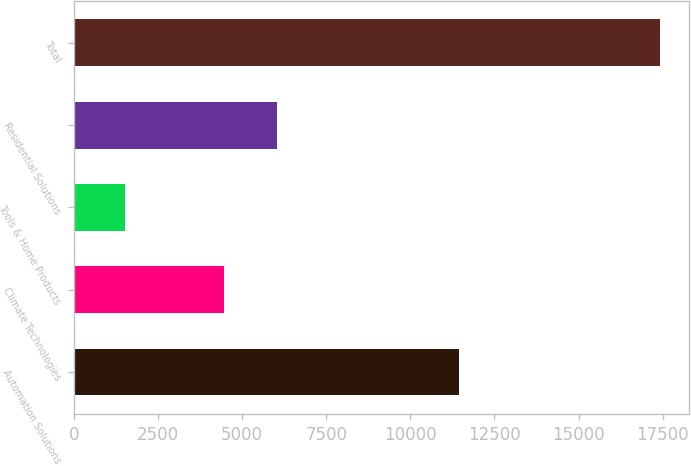<chart> <loc_0><loc_0><loc_500><loc_500><bar_chart><fcel>Automation Solutions<fcel>Climate Technologies<fcel>Tools & Home Products<fcel>Residential Solutions<fcel>Total<nl><fcel>11441<fcel>4454<fcel>1528<fcel>6042<fcel>17408<nl></chart> 